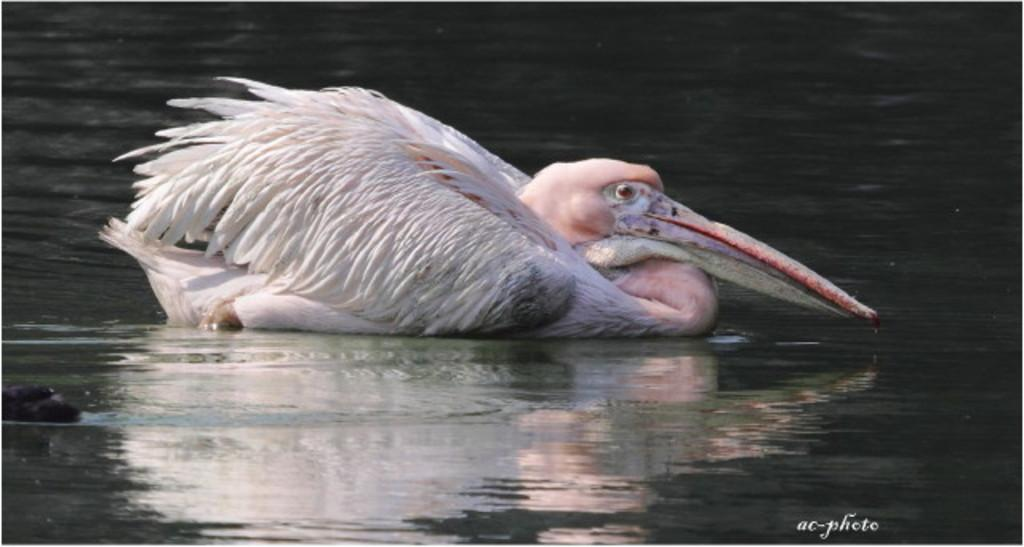Where was the image taken? The image is taken outdoors. What can be seen at the bottom of the image? There is a pond with water at the bottom of the image. What is in the pond in the middle of the image? There is a crane in the pond in the middle of the image. What type of railway is visible in the image? There is no railway present in the image. What emotion is being expressed by the crane in the image? The image does not depict emotions, and cranes do not have the ability to express emotions. 